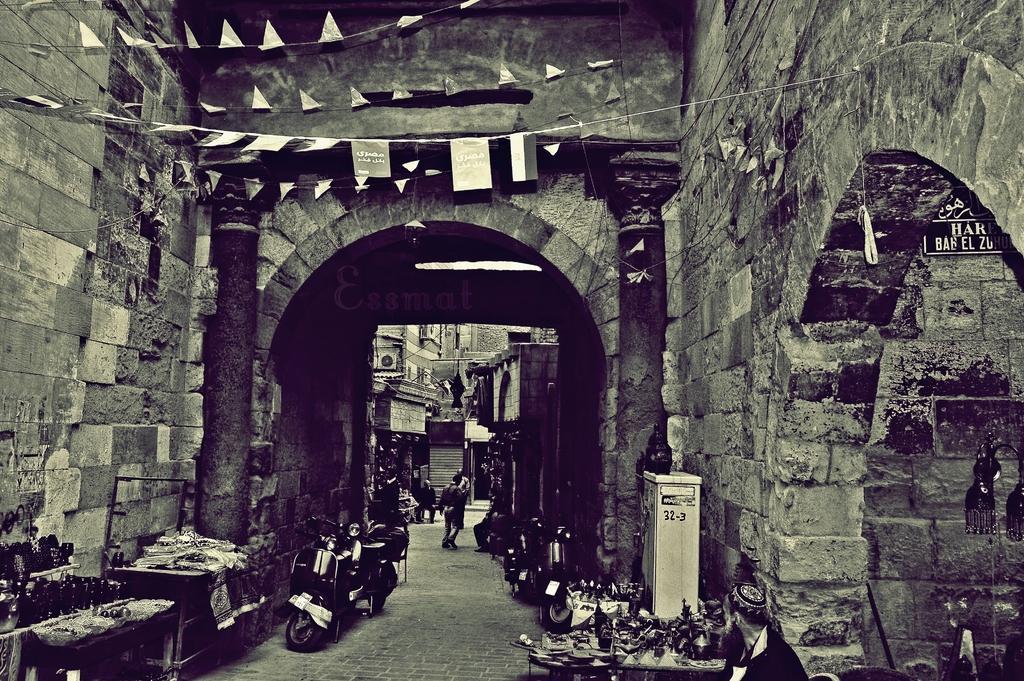Describe this image in one or two sentences. This is a black and white image. In this image we can see brick walls and pillars. Also there are scooters. And there are tables. On the tables there are many items. And there is a box. In the back there is a person and buildings. 